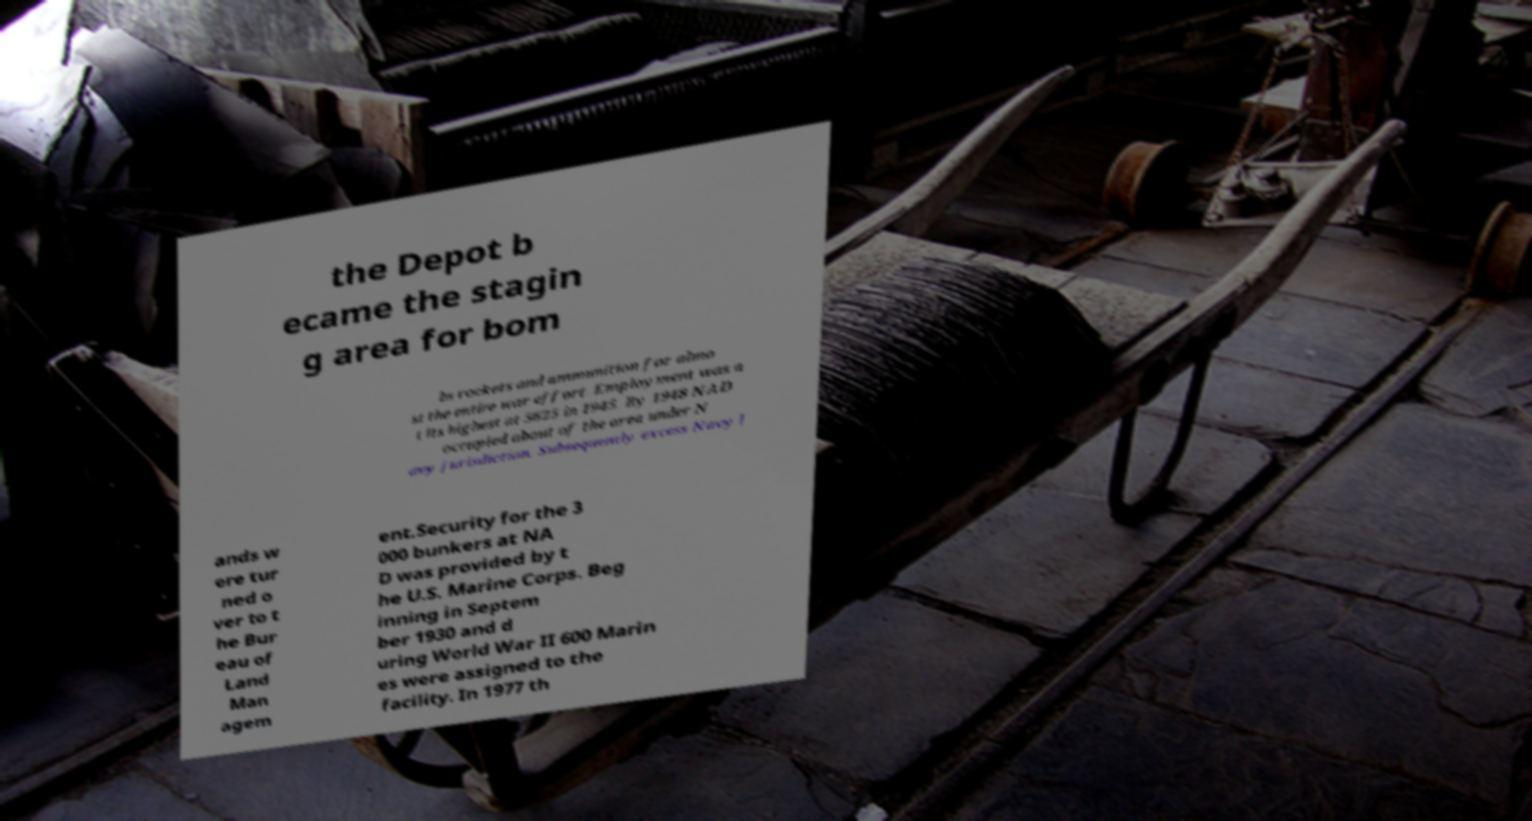Can you accurately transcribe the text from the provided image for me? the Depot b ecame the stagin g area for bom bs rockets and ammunition for almo st the entire war effort. Employment was a t its highest at 5625 in 1945. By 1948 NAD occupied about of the area under N avy jurisdiction. Subsequently excess Navy l ands w ere tur ned o ver to t he Bur eau of Land Man agem ent.Security for the 3 000 bunkers at NA D was provided by t he U.S. Marine Corps. Beg inning in Septem ber 1930 and d uring World War II 600 Marin es were assigned to the facility. In 1977 th 